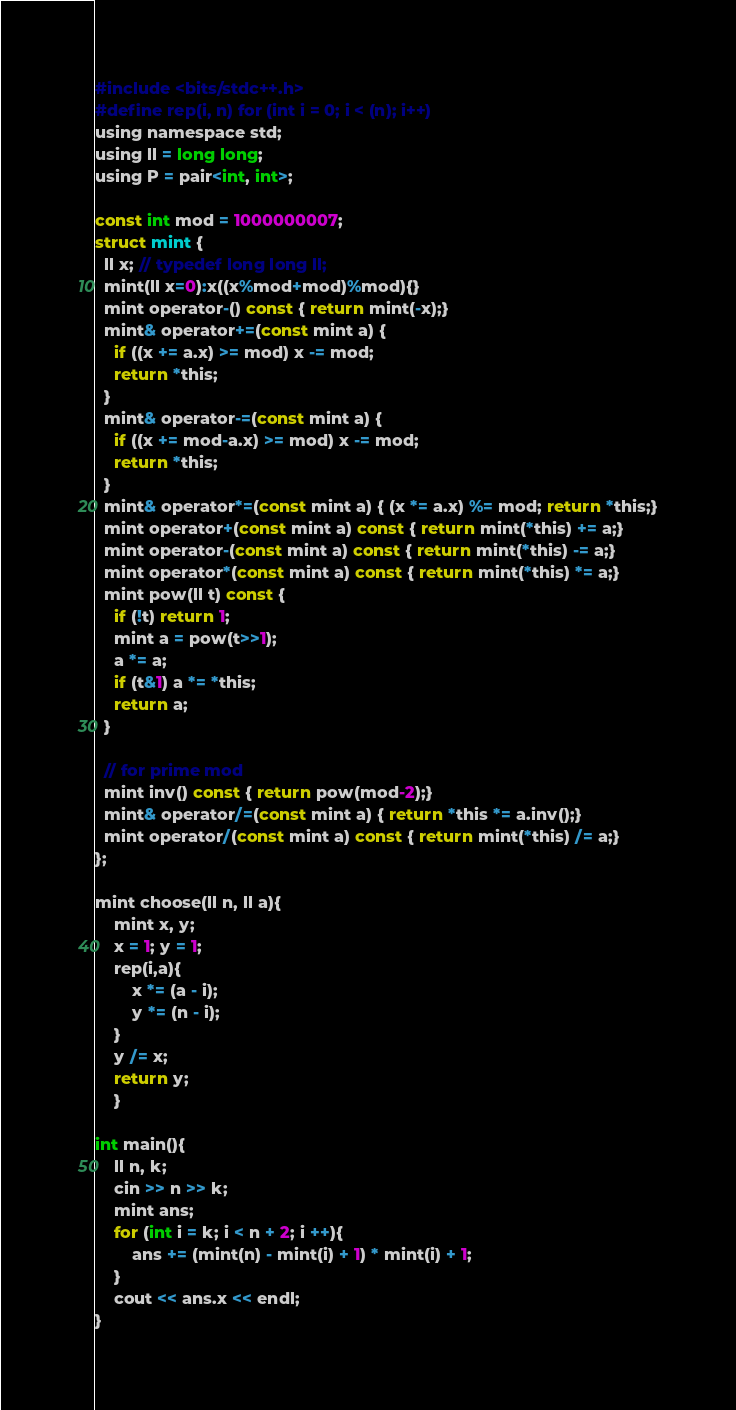Convert code to text. <code><loc_0><loc_0><loc_500><loc_500><_C_>#include <bits/stdc++.h>
#define rep(i, n) for (int i = 0; i < (n); i++)
using namespace std;
using ll = long long;
using P = pair<int, int>;

const int mod = 1000000007;
struct mint {
  ll x; // typedef long long ll;
  mint(ll x=0):x((x%mod+mod)%mod){}
  mint operator-() const { return mint(-x);}
  mint& operator+=(const mint a) {
    if ((x += a.x) >= mod) x -= mod;
    return *this;
  }
  mint& operator-=(const mint a) {
    if ((x += mod-a.x) >= mod) x -= mod;
    return *this;
  }
  mint& operator*=(const mint a) { (x *= a.x) %= mod; return *this;}
  mint operator+(const mint a) const { return mint(*this) += a;}
  mint operator-(const mint a) const { return mint(*this) -= a;}
  mint operator*(const mint a) const { return mint(*this) *= a;}
  mint pow(ll t) const {
    if (!t) return 1;
    mint a = pow(t>>1);
    a *= a;
    if (t&1) a *= *this;
    return a;
  }

  // for prime mod
  mint inv() const { return pow(mod-2);}
  mint& operator/=(const mint a) { return *this *= a.inv();}
  mint operator/(const mint a) const { return mint(*this) /= a;}
};

mint choose(ll n, ll a){
    mint x, y;
    x = 1; y = 1;
    rep(i,a){
        x *= (a - i);
        y *= (n - i);
    }
    y /= x;
    return y;
    }

int main(){
    ll n, k;
    cin >> n >> k;
    mint ans;
    for (int i = k; i < n + 2; i ++){
        ans += (mint(n) - mint(i) + 1) * mint(i) + 1;
    }
    cout << ans.x << endl;
}</code> 